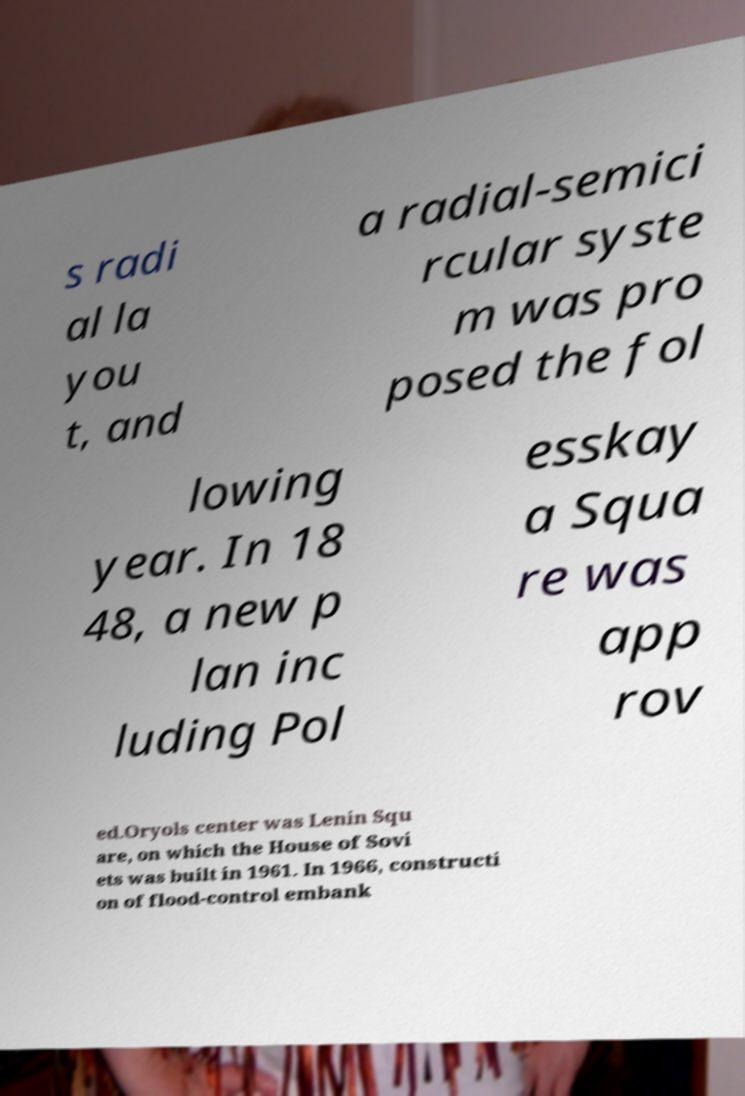Please identify and transcribe the text found in this image. s radi al la you t, and a radial-semici rcular syste m was pro posed the fol lowing year. In 18 48, a new p lan inc luding Pol esskay a Squa re was app rov ed.Oryols center was Lenin Squ are, on which the House of Sovi ets was built in 1961. In 1966, constructi on of flood-control embank 